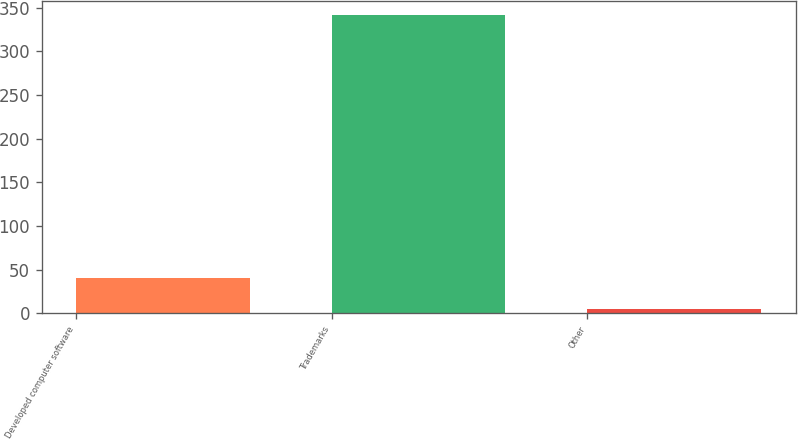Convert chart. <chart><loc_0><loc_0><loc_500><loc_500><bar_chart><fcel>Developed computer software<fcel>Trademarks<fcel>Other<nl><fcel>40<fcel>341.1<fcel>4.9<nl></chart> 